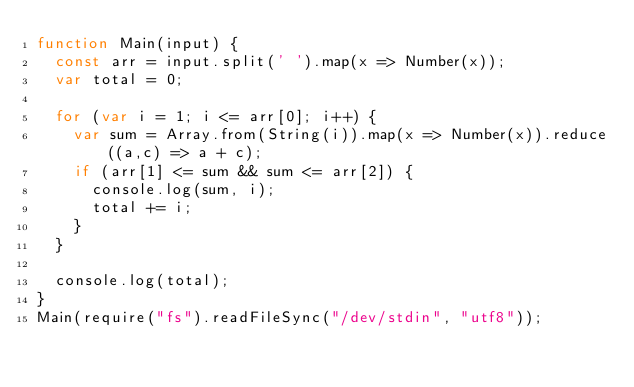<code> <loc_0><loc_0><loc_500><loc_500><_JavaScript_>function Main(input) {
  const arr = input.split(' ').map(x => Number(x));
  var total = 0;

  for (var i = 1; i <= arr[0]; i++) {
    var sum = Array.from(String(i)).map(x => Number(x)).reduce((a,c) => a + c);
    if (arr[1] <= sum && sum <= arr[2]) {
      console.log(sum, i);
      total += i;
    }
  }

  console.log(total);
}
Main(require("fs").readFileSync("/dev/stdin", "utf8"));</code> 